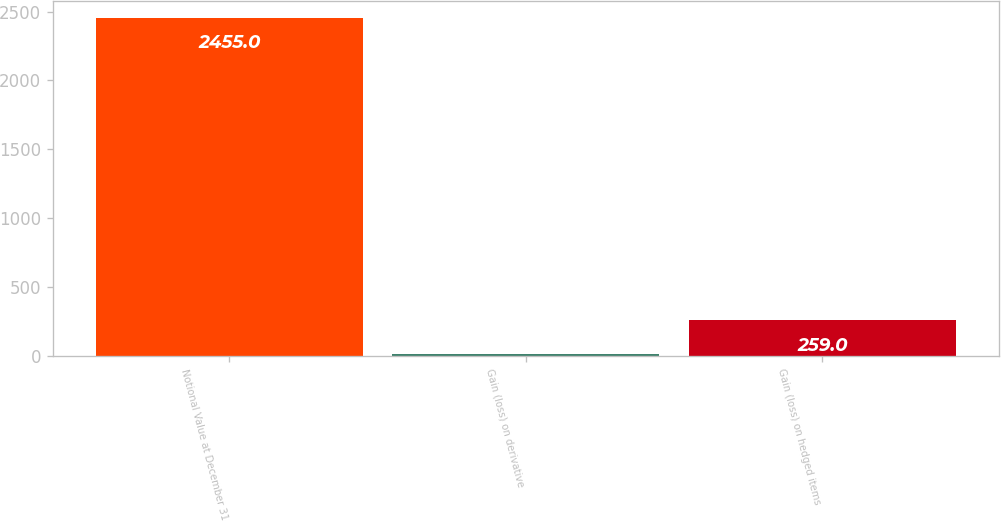<chart> <loc_0><loc_0><loc_500><loc_500><bar_chart><fcel>Notional Value at December 31<fcel>Gain (loss) on derivative<fcel>Gain (loss) on hedged items<nl><fcel>2455<fcel>15<fcel>259<nl></chart> 